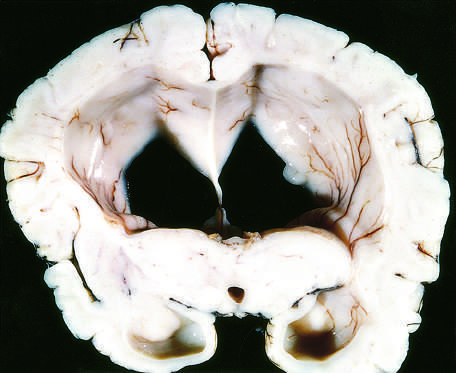what are the surfaces of the gyri flattened as a result of?
Answer the question using a single word or phrase. Compression of the expanding brain by the dura mater and inner surface of the skull 